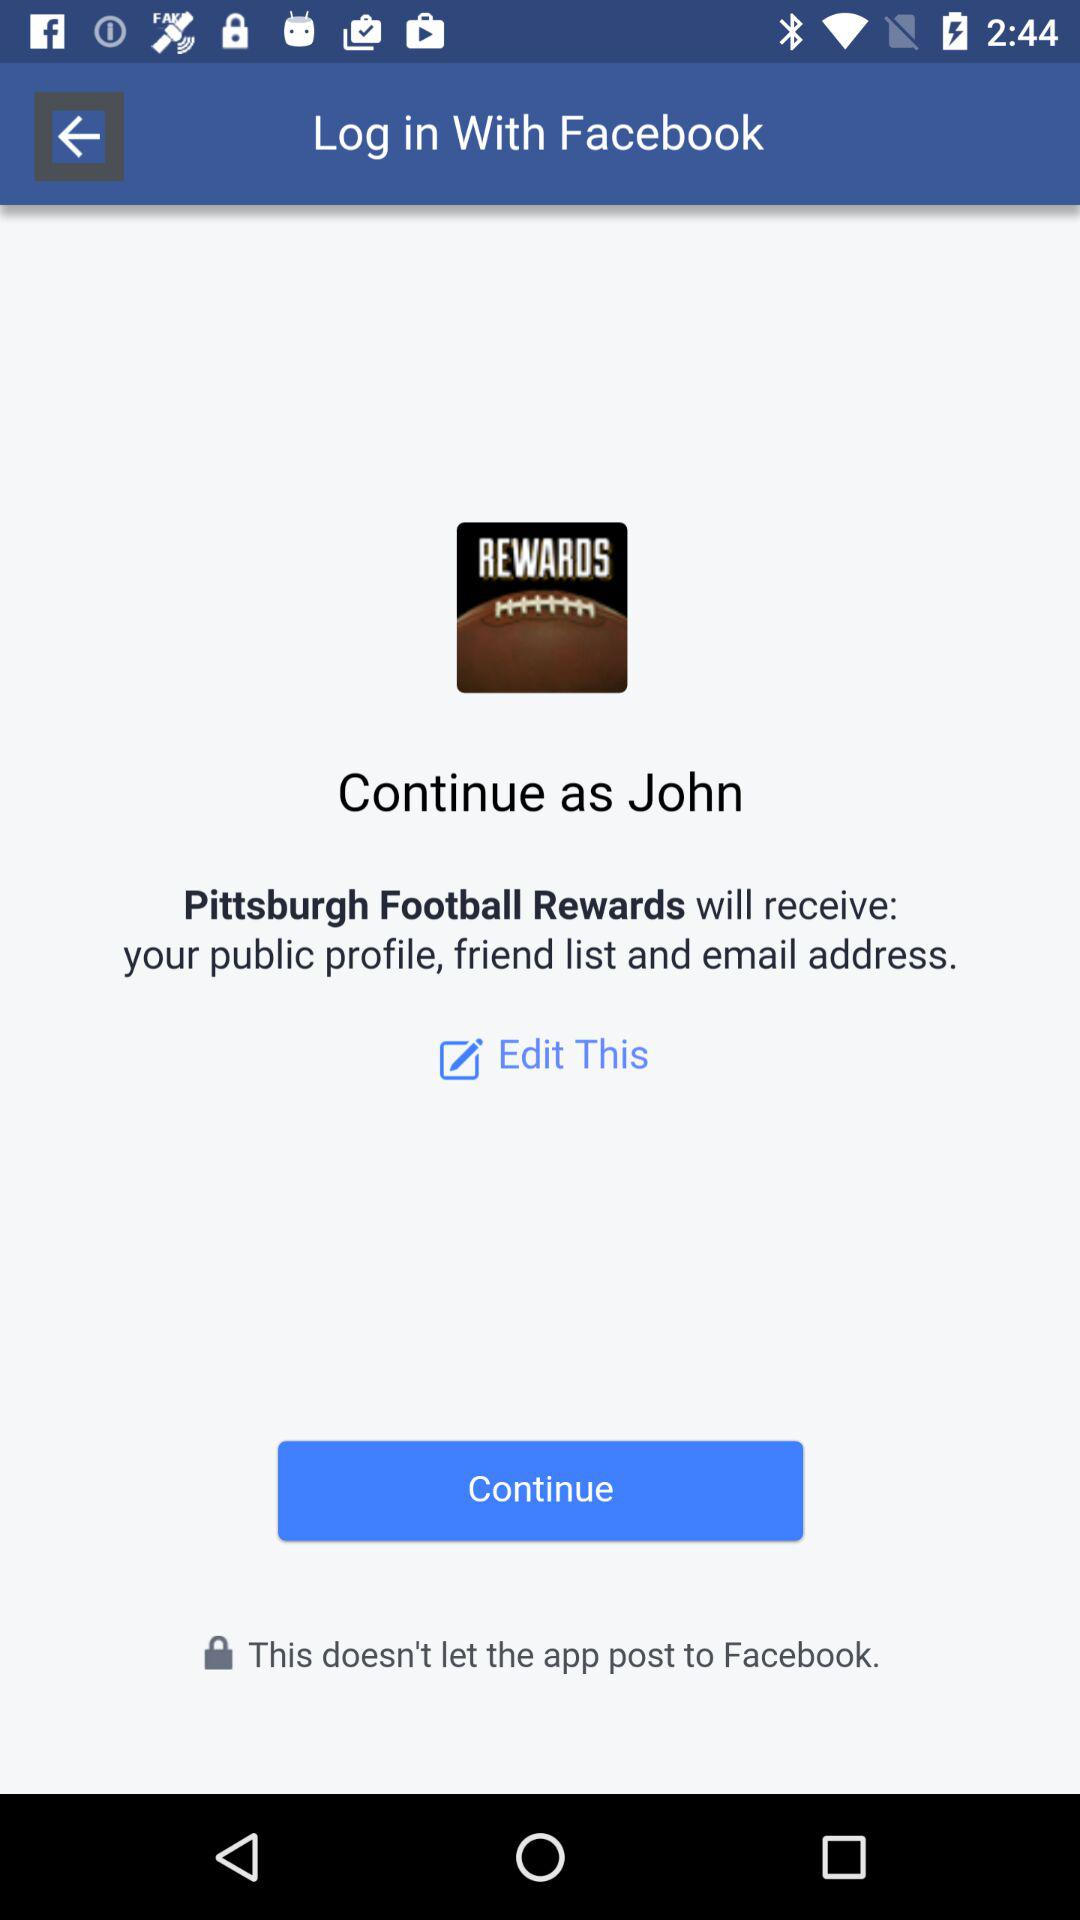What is the login profile name? The login profile name is John. 